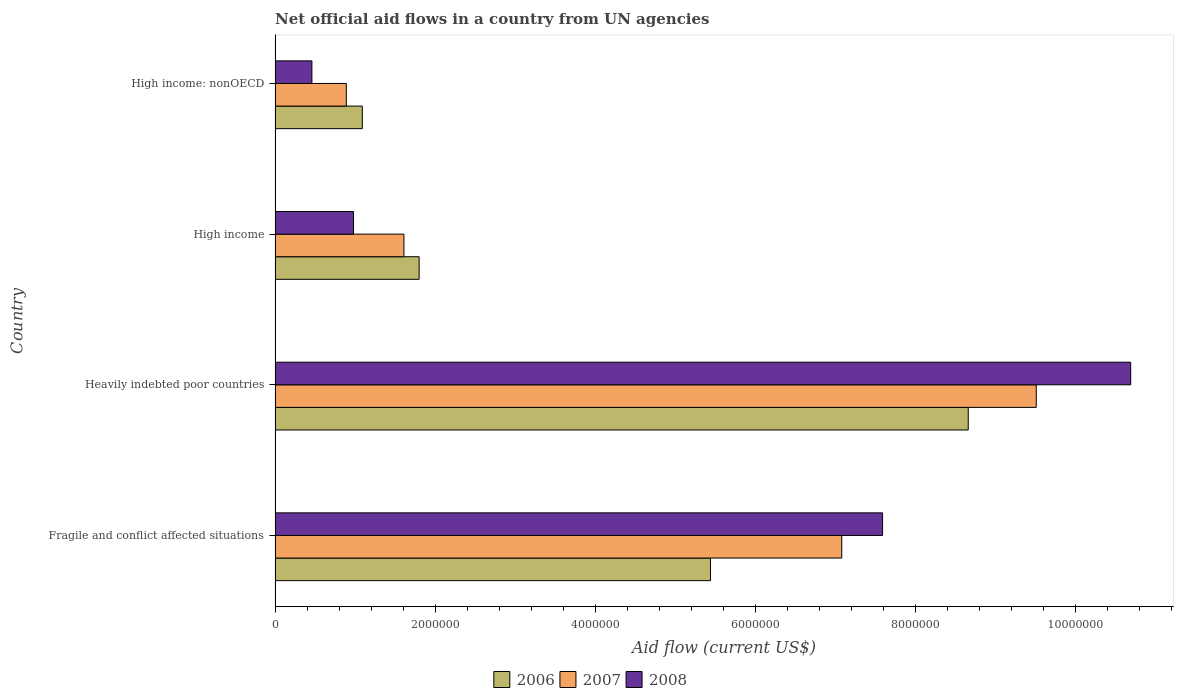How many groups of bars are there?
Keep it short and to the point. 4. How many bars are there on the 4th tick from the top?
Offer a very short reply. 3. How many bars are there on the 4th tick from the bottom?
Provide a succinct answer. 3. What is the label of the 4th group of bars from the top?
Keep it short and to the point. Fragile and conflict affected situations. What is the net official aid flow in 2007 in Heavily indebted poor countries?
Make the answer very short. 9.51e+06. Across all countries, what is the maximum net official aid flow in 2006?
Keep it short and to the point. 8.66e+06. Across all countries, what is the minimum net official aid flow in 2007?
Offer a terse response. 8.90e+05. In which country was the net official aid flow in 2006 maximum?
Your answer should be very brief. Heavily indebted poor countries. In which country was the net official aid flow in 2007 minimum?
Offer a very short reply. High income: nonOECD. What is the total net official aid flow in 2007 in the graph?
Provide a short and direct response. 1.91e+07. What is the difference between the net official aid flow in 2006 in High income and that in High income: nonOECD?
Offer a terse response. 7.10e+05. What is the difference between the net official aid flow in 2008 in Fragile and conflict affected situations and the net official aid flow in 2006 in High income: nonOECD?
Keep it short and to the point. 6.50e+06. What is the average net official aid flow in 2006 per country?
Keep it short and to the point. 4.25e+06. What is the difference between the net official aid flow in 2007 and net official aid flow in 2006 in High income?
Your answer should be very brief. -1.90e+05. In how many countries, is the net official aid flow in 2006 greater than 800000 US$?
Keep it short and to the point. 4. What is the ratio of the net official aid flow in 2006 in Fragile and conflict affected situations to that in High income: nonOECD?
Provide a short and direct response. 4.99. What is the difference between the highest and the second highest net official aid flow in 2007?
Give a very brief answer. 2.43e+06. What is the difference between the highest and the lowest net official aid flow in 2006?
Keep it short and to the point. 7.57e+06. In how many countries, is the net official aid flow in 2008 greater than the average net official aid flow in 2008 taken over all countries?
Your answer should be very brief. 2. Is the sum of the net official aid flow in 2007 in Heavily indebted poor countries and High income: nonOECD greater than the maximum net official aid flow in 2008 across all countries?
Your answer should be compact. No. What does the 3rd bar from the bottom in High income: nonOECD represents?
Your answer should be compact. 2008. What is the difference between two consecutive major ticks on the X-axis?
Your answer should be very brief. 2.00e+06. Does the graph contain any zero values?
Make the answer very short. No. Does the graph contain grids?
Offer a terse response. No. How many legend labels are there?
Ensure brevity in your answer.  3. How are the legend labels stacked?
Your response must be concise. Horizontal. What is the title of the graph?
Provide a short and direct response. Net official aid flows in a country from UN agencies. What is the label or title of the Y-axis?
Ensure brevity in your answer.  Country. What is the Aid flow (current US$) in 2006 in Fragile and conflict affected situations?
Offer a terse response. 5.44e+06. What is the Aid flow (current US$) in 2007 in Fragile and conflict affected situations?
Offer a very short reply. 7.08e+06. What is the Aid flow (current US$) in 2008 in Fragile and conflict affected situations?
Give a very brief answer. 7.59e+06. What is the Aid flow (current US$) in 2006 in Heavily indebted poor countries?
Your answer should be compact. 8.66e+06. What is the Aid flow (current US$) in 2007 in Heavily indebted poor countries?
Provide a succinct answer. 9.51e+06. What is the Aid flow (current US$) in 2008 in Heavily indebted poor countries?
Make the answer very short. 1.07e+07. What is the Aid flow (current US$) in 2006 in High income?
Offer a very short reply. 1.80e+06. What is the Aid flow (current US$) of 2007 in High income?
Provide a succinct answer. 1.61e+06. What is the Aid flow (current US$) of 2008 in High income?
Give a very brief answer. 9.80e+05. What is the Aid flow (current US$) of 2006 in High income: nonOECD?
Provide a succinct answer. 1.09e+06. What is the Aid flow (current US$) of 2007 in High income: nonOECD?
Provide a short and direct response. 8.90e+05. What is the Aid flow (current US$) of 2008 in High income: nonOECD?
Offer a terse response. 4.60e+05. Across all countries, what is the maximum Aid flow (current US$) in 2006?
Your response must be concise. 8.66e+06. Across all countries, what is the maximum Aid flow (current US$) in 2007?
Keep it short and to the point. 9.51e+06. Across all countries, what is the maximum Aid flow (current US$) in 2008?
Give a very brief answer. 1.07e+07. Across all countries, what is the minimum Aid flow (current US$) in 2006?
Give a very brief answer. 1.09e+06. Across all countries, what is the minimum Aid flow (current US$) in 2007?
Offer a terse response. 8.90e+05. What is the total Aid flow (current US$) in 2006 in the graph?
Your response must be concise. 1.70e+07. What is the total Aid flow (current US$) of 2007 in the graph?
Provide a short and direct response. 1.91e+07. What is the total Aid flow (current US$) of 2008 in the graph?
Offer a terse response. 1.97e+07. What is the difference between the Aid flow (current US$) of 2006 in Fragile and conflict affected situations and that in Heavily indebted poor countries?
Give a very brief answer. -3.22e+06. What is the difference between the Aid flow (current US$) in 2007 in Fragile and conflict affected situations and that in Heavily indebted poor countries?
Your answer should be very brief. -2.43e+06. What is the difference between the Aid flow (current US$) of 2008 in Fragile and conflict affected situations and that in Heavily indebted poor countries?
Your answer should be very brief. -3.10e+06. What is the difference between the Aid flow (current US$) in 2006 in Fragile and conflict affected situations and that in High income?
Your answer should be compact. 3.64e+06. What is the difference between the Aid flow (current US$) of 2007 in Fragile and conflict affected situations and that in High income?
Provide a succinct answer. 5.47e+06. What is the difference between the Aid flow (current US$) of 2008 in Fragile and conflict affected situations and that in High income?
Give a very brief answer. 6.61e+06. What is the difference between the Aid flow (current US$) of 2006 in Fragile and conflict affected situations and that in High income: nonOECD?
Give a very brief answer. 4.35e+06. What is the difference between the Aid flow (current US$) of 2007 in Fragile and conflict affected situations and that in High income: nonOECD?
Provide a succinct answer. 6.19e+06. What is the difference between the Aid flow (current US$) of 2008 in Fragile and conflict affected situations and that in High income: nonOECD?
Your answer should be compact. 7.13e+06. What is the difference between the Aid flow (current US$) of 2006 in Heavily indebted poor countries and that in High income?
Your answer should be very brief. 6.86e+06. What is the difference between the Aid flow (current US$) in 2007 in Heavily indebted poor countries and that in High income?
Offer a terse response. 7.90e+06. What is the difference between the Aid flow (current US$) in 2008 in Heavily indebted poor countries and that in High income?
Give a very brief answer. 9.71e+06. What is the difference between the Aid flow (current US$) in 2006 in Heavily indebted poor countries and that in High income: nonOECD?
Provide a succinct answer. 7.57e+06. What is the difference between the Aid flow (current US$) of 2007 in Heavily indebted poor countries and that in High income: nonOECD?
Make the answer very short. 8.62e+06. What is the difference between the Aid flow (current US$) of 2008 in Heavily indebted poor countries and that in High income: nonOECD?
Give a very brief answer. 1.02e+07. What is the difference between the Aid flow (current US$) in 2006 in High income and that in High income: nonOECD?
Make the answer very short. 7.10e+05. What is the difference between the Aid flow (current US$) of 2007 in High income and that in High income: nonOECD?
Your response must be concise. 7.20e+05. What is the difference between the Aid flow (current US$) in 2008 in High income and that in High income: nonOECD?
Provide a succinct answer. 5.20e+05. What is the difference between the Aid flow (current US$) in 2006 in Fragile and conflict affected situations and the Aid flow (current US$) in 2007 in Heavily indebted poor countries?
Your response must be concise. -4.07e+06. What is the difference between the Aid flow (current US$) of 2006 in Fragile and conflict affected situations and the Aid flow (current US$) of 2008 in Heavily indebted poor countries?
Provide a short and direct response. -5.25e+06. What is the difference between the Aid flow (current US$) in 2007 in Fragile and conflict affected situations and the Aid flow (current US$) in 2008 in Heavily indebted poor countries?
Ensure brevity in your answer.  -3.61e+06. What is the difference between the Aid flow (current US$) of 2006 in Fragile and conflict affected situations and the Aid flow (current US$) of 2007 in High income?
Make the answer very short. 3.83e+06. What is the difference between the Aid flow (current US$) of 2006 in Fragile and conflict affected situations and the Aid flow (current US$) of 2008 in High income?
Keep it short and to the point. 4.46e+06. What is the difference between the Aid flow (current US$) in 2007 in Fragile and conflict affected situations and the Aid flow (current US$) in 2008 in High income?
Your answer should be very brief. 6.10e+06. What is the difference between the Aid flow (current US$) in 2006 in Fragile and conflict affected situations and the Aid flow (current US$) in 2007 in High income: nonOECD?
Your answer should be compact. 4.55e+06. What is the difference between the Aid flow (current US$) in 2006 in Fragile and conflict affected situations and the Aid flow (current US$) in 2008 in High income: nonOECD?
Your answer should be compact. 4.98e+06. What is the difference between the Aid flow (current US$) in 2007 in Fragile and conflict affected situations and the Aid flow (current US$) in 2008 in High income: nonOECD?
Offer a very short reply. 6.62e+06. What is the difference between the Aid flow (current US$) in 2006 in Heavily indebted poor countries and the Aid flow (current US$) in 2007 in High income?
Your answer should be very brief. 7.05e+06. What is the difference between the Aid flow (current US$) of 2006 in Heavily indebted poor countries and the Aid flow (current US$) of 2008 in High income?
Your answer should be compact. 7.68e+06. What is the difference between the Aid flow (current US$) in 2007 in Heavily indebted poor countries and the Aid flow (current US$) in 2008 in High income?
Ensure brevity in your answer.  8.53e+06. What is the difference between the Aid flow (current US$) of 2006 in Heavily indebted poor countries and the Aid flow (current US$) of 2007 in High income: nonOECD?
Make the answer very short. 7.77e+06. What is the difference between the Aid flow (current US$) in 2006 in Heavily indebted poor countries and the Aid flow (current US$) in 2008 in High income: nonOECD?
Your response must be concise. 8.20e+06. What is the difference between the Aid flow (current US$) of 2007 in Heavily indebted poor countries and the Aid flow (current US$) of 2008 in High income: nonOECD?
Make the answer very short. 9.05e+06. What is the difference between the Aid flow (current US$) of 2006 in High income and the Aid flow (current US$) of 2007 in High income: nonOECD?
Provide a short and direct response. 9.10e+05. What is the difference between the Aid flow (current US$) in 2006 in High income and the Aid flow (current US$) in 2008 in High income: nonOECD?
Ensure brevity in your answer.  1.34e+06. What is the difference between the Aid flow (current US$) of 2007 in High income and the Aid flow (current US$) of 2008 in High income: nonOECD?
Provide a short and direct response. 1.15e+06. What is the average Aid flow (current US$) of 2006 per country?
Offer a very short reply. 4.25e+06. What is the average Aid flow (current US$) in 2007 per country?
Your response must be concise. 4.77e+06. What is the average Aid flow (current US$) of 2008 per country?
Your answer should be very brief. 4.93e+06. What is the difference between the Aid flow (current US$) of 2006 and Aid flow (current US$) of 2007 in Fragile and conflict affected situations?
Keep it short and to the point. -1.64e+06. What is the difference between the Aid flow (current US$) in 2006 and Aid flow (current US$) in 2008 in Fragile and conflict affected situations?
Offer a terse response. -2.15e+06. What is the difference between the Aid flow (current US$) in 2007 and Aid flow (current US$) in 2008 in Fragile and conflict affected situations?
Make the answer very short. -5.10e+05. What is the difference between the Aid flow (current US$) of 2006 and Aid flow (current US$) of 2007 in Heavily indebted poor countries?
Your response must be concise. -8.50e+05. What is the difference between the Aid flow (current US$) of 2006 and Aid flow (current US$) of 2008 in Heavily indebted poor countries?
Your answer should be compact. -2.03e+06. What is the difference between the Aid flow (current US$) of 2007 and Aid flow (current US$) of 2008 in Heavily indebted poor countries?
Provide a succinct answer. -1.18e+06. What is the difference between the Aid flow (current US$) of 2006 and Aid flow (current US$) of 2007 in High income?
Give a very brief answer. 1.90e+05. What is the difference between the Aid flow (current US$) of 2006 and Aid flow (current US$) of 2008 in High income?
Your answer should be very brief. 8.20e+05. What is the difference between the Aid flow (current US$) of 2007 and Aid flow (current US$) of 2008 in High income?
Give a very brief answer. 6.30e+05. What is the difference between the Aid flow (current US$) of 2006 and Aid flow (current US$) of 2007 in High income: nonOECD?
Keep it short and to the point. 2.00e+05. What is the difference between the Aid flow (current US$) in 2006 and Aid flow (current US$) in 2008 in High income: nonOECD?
Your response must be concise. 6.30e+05. What is the ratio of the Aid flow (current US$) in 2006 in Fragile and conflict affected situations to that in Heavily indebted poor countries?
Your answer should be compact. 0.63. What is the ratio of the Aid flow (current US$) of 2007 in Fragile and conflict affected situations to that in Heavily indebted poor countries?
Keep it short and to the point. 0.74. What is the ratio of the Aid flow (current US$) in 2008 in Fragile and conflict affected situations to that in Heavily indebted poor countries?
Your answer should be compact. 0.71. What is the ratio of the Aid flow (current US$) of 2006 in Fragile and conflict affected situations to that in High income?
Provide a short and direct response. 3.02. What is the ratio of the Aid flow (current US$) in 2007 in Fragile and conflict affected situations to that in High income?
Ensure brevity in your answer.  4.4. What is the ratio of the Aid flow (current US$) in 2008 in Fragile and conflict affected situations to that in High income?
Ensure brevity in your answer.  7.74. What is the ratio of the Aid flow (current US$) of 2006 in Fragile and conflict affected situations to that in High income: nonOECD?
Give a very brief answer. 4.99. What is the ratio of the Aid flow (current US$) of 2007 in Fragile and conflict affected situations to that in High income: nonOECD?
Your answer should be very brief. 7.96. What is the ratio of the Aid flow (current US$) of 2008 in Fragile and conflict affected situations to that in High income: nonOECD?
Give a very brief answer. 16.5. What is the ratio of the Aid flow (current US$) of 2006 in Heavily indebted poor countries to that in High income?
Give a very brief answer. 4.81. What is the ratio of the Aid flow (current US$) of 2007 in Heavily indebted poor countries to that in High income?
Your answer should be compact. 5.91. What is the ratio of the Aid flow (current US$) of 2008 in Heavily indebted poor countries to that in High income?
Give a very brief answer. 10.91. What is the ratio of the Aid flow (current US$) of 2006 in Heavily indebted poor countries to that in High income: nonOECD?
Give a very brief answer. 7.95. What is the ratio of the Aid flow (current US$) of 2007 in Heavily indebted poor countries to that in High income: nonOECD?
Your response must be concise. 10.69. What is the ratio of the Aid flow (current US$) of 2008 in Heavily indebted poor countries to that in High income: nonOECD?
Give a very brief answer. 23.24. What is the ratio of the Aid flow (current US$) in 2006 in High income to that in High income: nonOECD?
Your answer should be very brief. 1.65. What is the ratio of the Aid flow (current US$) in 2007 in High income to that in High income: nonOECD?
Offer a terse response. 1.81. What is the ratio of the Aid flow (current US$) of 2008 in High income to that in High income: nonOECD?
Provide a short and direct response. 2.13. What is the difference between the highest and the second highest Aid flow (current US$) in 2006?
Your answer should be compact. 3.22e+06. What is the difference between the highest and the second highest Aid flow (current US$) of 2007?
Offer a very short reply. 2.43e+06. What is the difference between the highest and the second highest Aid flow (current US$) in 2008?
Provide a short and direct response. 3.10e+06. What is the difference between the highest and the lowest Aid flow (current US$) of 2006?
Give a very brief answer. 7.57e+06. What is the difference between the highest and the lowest Aid flow (current US$) of 2007?
Keep it short and to the point. 8.62e+06. What is the difference between the highest and the lowest Aid flow (current US$) in 2008?
Keep it short and to the point. 1.02e+07. 